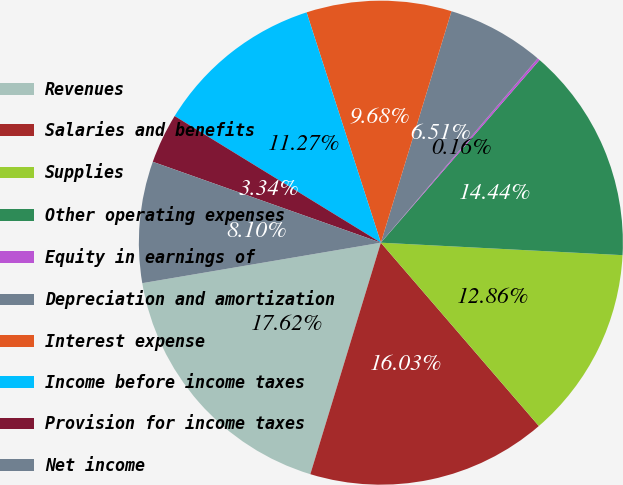Convert chart. <chart><loc_0><loc_0><loc_500><loc_500><pie_chart><fcel>Revenues<fcel>Salaries and benefits<fcel>Supplies<fcel>Other operating expenses<fcel>Equity in earnings of<fcel>Depreciation and amortization<fcel>Interest expense<fcel>Income before income taxes<fcel>Provision for income taxes<fcel>Net income<nl><fcel>17.62%<fcel>16.03%<fcel>12.86%<fcel>14.44%<fcel>0.16%<fcel>6.51%<fcel>9.68%<fcel>11.27%<fcel>3.34%<fcel>8.1%<nl></chart> 